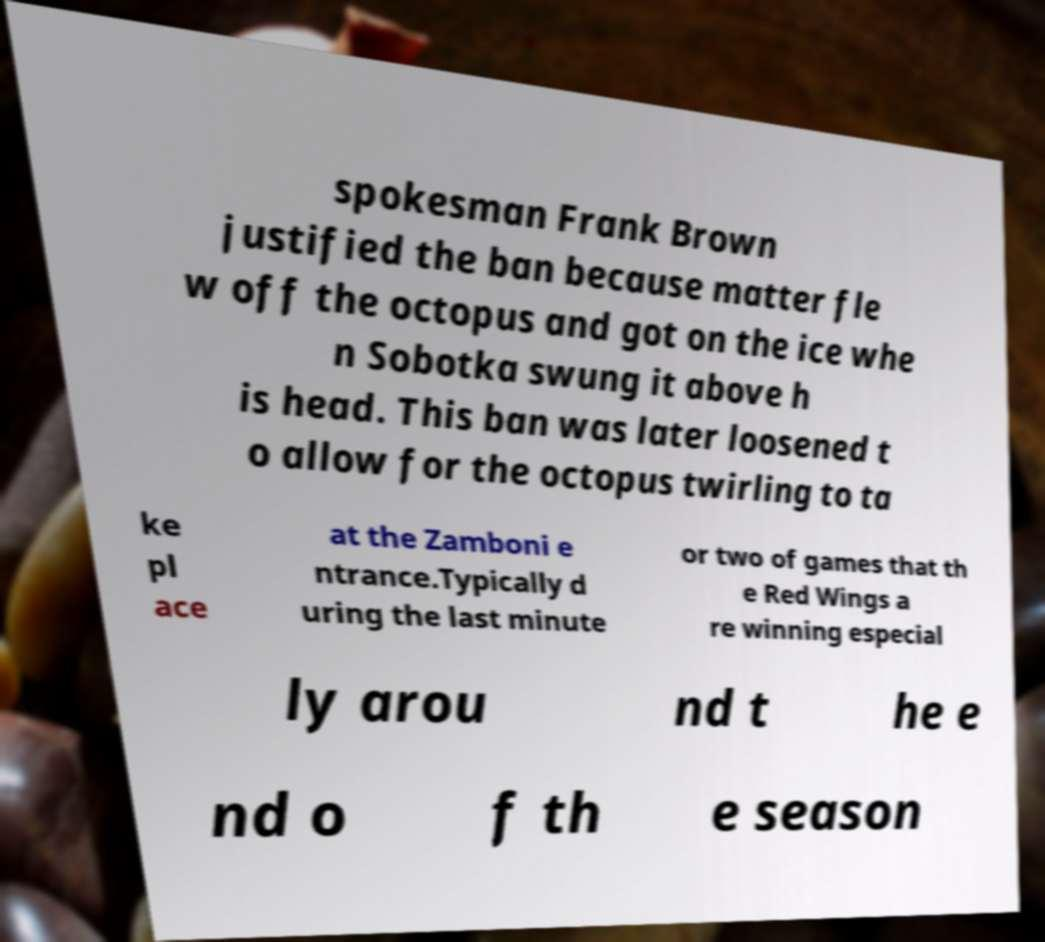Can you accurately transcribe the text from the provided image for me? spokesman Frank Brown justified the ban because matter fle w off the octopus and got on the ice whe n Sobotka swung it above h is head. This ban was later loosened t o allow for the octopus twirling to ta ke pl ace at the Zamboni e ntrance.Typically d uring the last minute or two of games that th e Red Wings a re winning especial ly arou nd t he e nd o f th e season 